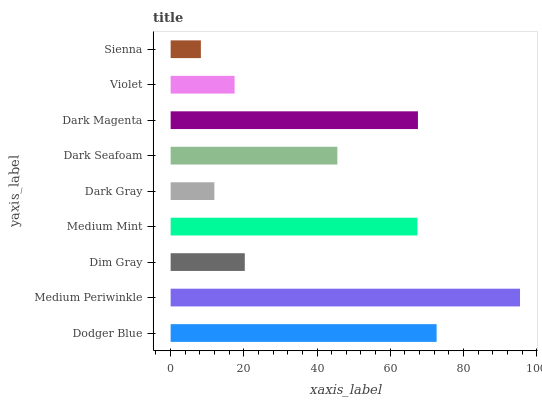Is Sienna the minimum?
Answer yes or no. Yes. Is Medium Periwinkle the maximum?
Answer yes or no. Yes. Is Dim Gray the minimum?
Answer yes or no. No. Is Dim Gray the maximum?
Answer yes or no. No. Is Medium Periwinkle greater than Dim Gray?
Answer yes or no. Yes. Is Dim Gray less than Medium Periwinkle?
Answer yes or no. Yes. Is Dim Gray greater than Medium Periwinkle?
Answer yes or no. No. Is Medium Periwinkle less than Dim Gray?
Answer yes or no. No. Is Dark Seafoam the high median?
Answer yes or no. Yes. Is Dark Seafoam the low median?
Answer yes or no. Yes. Is Dodger Blue the high median?
Answer yes or no. No. Is Dark Gray the low median?
Answer yes or no. No. 